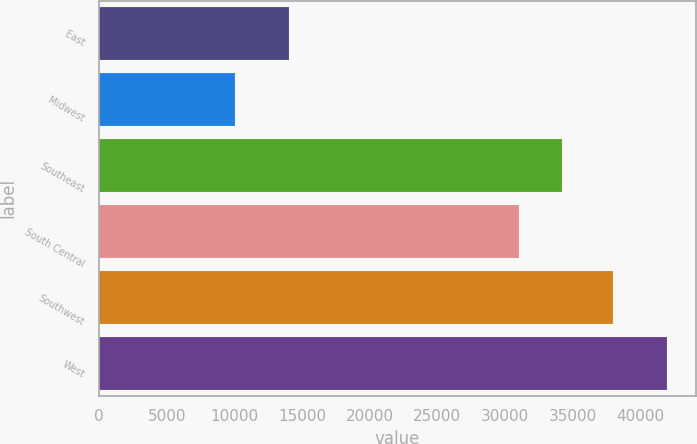Convert chart to OTSL. <chart><loc_0><loc_0><loc_500><loc_500><bar_chart><fcel>East<fcel>Midwest<fcel>Southeast<fcel>South Central<fcel>Southwest<fcel>West<nl><fcel>14000<fcel>10000<fcel>34200<fcel>31000<fcel>38000<fcel>42000<nl></chart> 